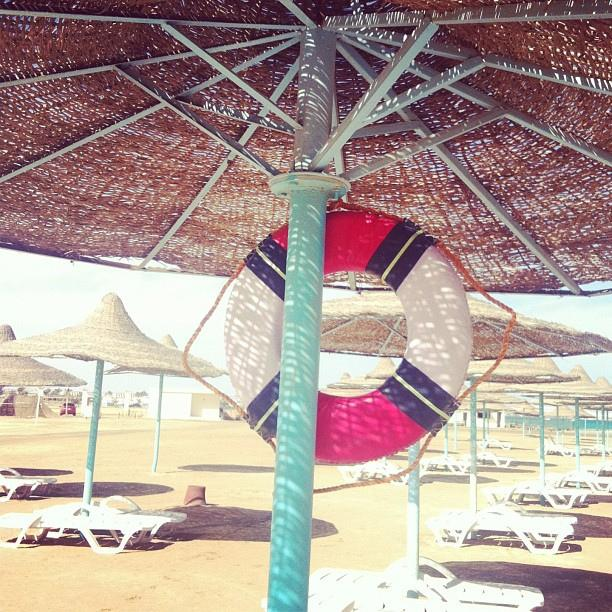The shade held by the teal umbrella pole was crafted in which manner? Please explain your reasoning. weaving. The shade is woven. 